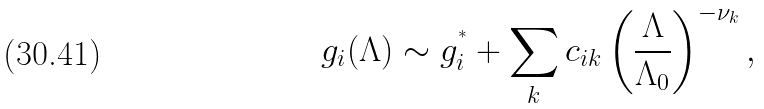Convert formula to latex. <formula><loc_0><loc_0><loc_500><loc_500>g _ { i } ( \Lambda ) \sim g ^ { ^ { * } } _ { i } + \sum _ { k } c _ { i k } \left ( \frac { \Lambda } { \Lambda _ { 0 } } \right ) ^ { - \nu _ { k } } ,</formula> 